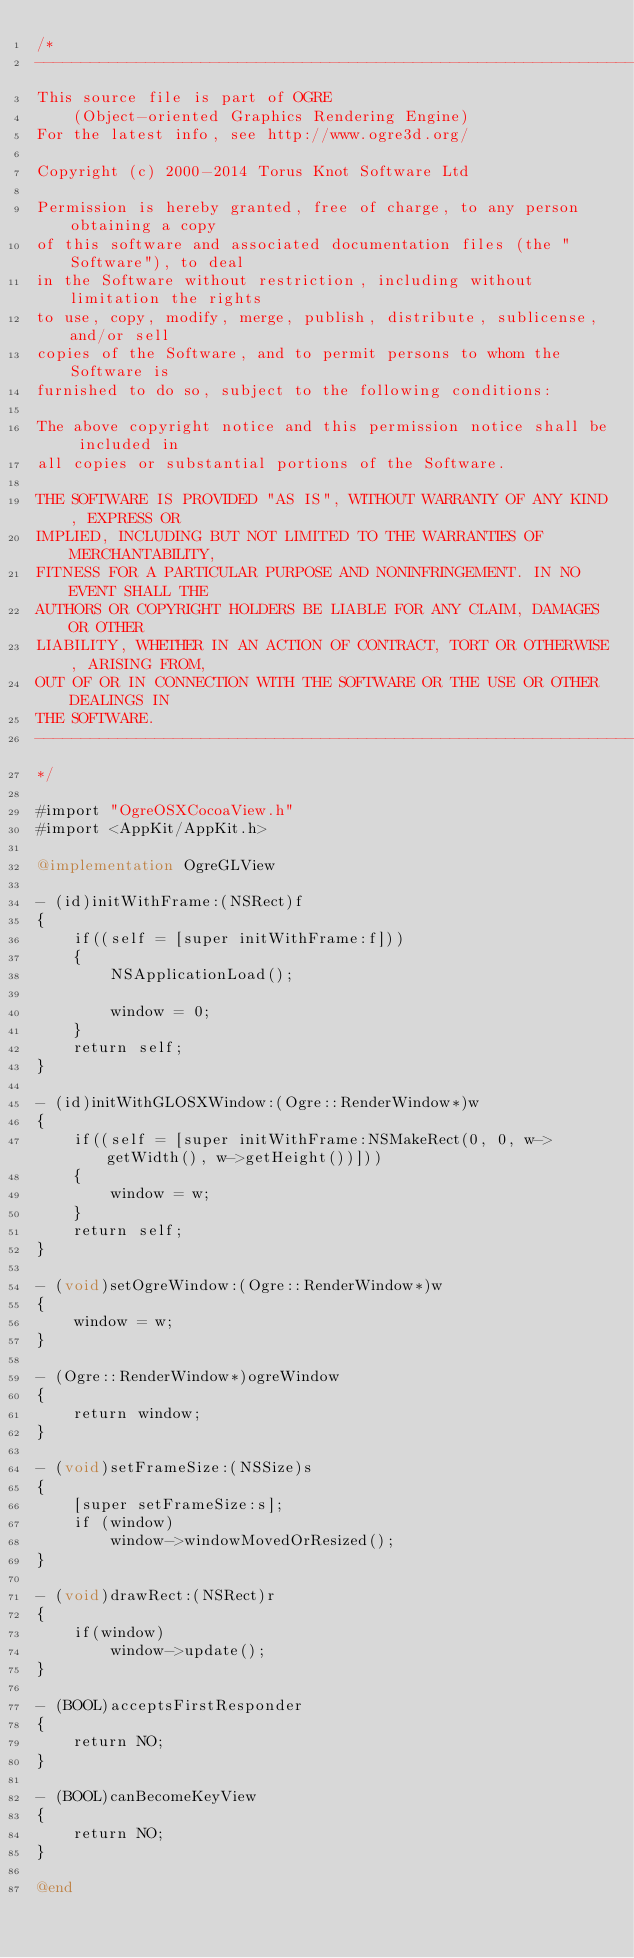Convert code to text. <code><loc_0><loc_0><loc_500><loc_500><_ObjectiveC_>/*
-----------------------------------------------------------------------------
This source file is part of OGRE
    (Object-oriented Graphics Rendering Engine)
For the latest info, see http://www.ogre3d.org/

Copyright (c) 2000-2014 Torus Knot Software Ltd

Permission is hereby granted, free of charge, to any person obtaining a copy
of this software and associated documentation files (the "Software"), to deal
in the Software without restriction, including without limitation the rights
to use, copy, modify, merge, publish, distribute, sublicense, and/or sell
copies of the Software, and to permit persons to whom the Software is
furnished to do so, subject to the following conditions:

The above copyright notice and this permission notice shall be included in
all copies or substantial portions of the Software.

THE SOFTWARE IS PROVIDED "AS IS", WITHOUT WARRANTY OF ANY KIND, EXPRESS OR
IMPLIED, INCLUDING BUT NOT LIMITED TO THE WARRANTIES OF MERCHANTABILITY,
FITNESS FOR A PARTICULAR PURPOSE AND NONINFRINGEMENT. IN NO EVENT SHALL THE
AUTHORS OR COPYRIGHT HOLDERS BE LIABLE FOR ANY CLAIM, DAMAGES OR OTHER
LIABILITY, WHETHER IN AN ACTION OF CONTRACT, TORT OR OTHERWISE, ARISING FROM,
OUT OF OR IN CONNECTION WITH THE SOFTWARE OR THE USE OR OTHER DEALINGS IN
THE SOFTWARE.
-----------------------------------------------------------------------------
*/

#import "OgreOSXCocoaView.h"
#import <AppKit/AppKit.h>

@implementation OgreGLView

- (id)initWithFrame:(NSRect)f
{
	if((self = [super initWithFrame:f]))
    {
        NSApplicationLoad();
        
        window = 0;
    }
	return self;
}

- (id)initWithGLOSXWindow:(Ogre::RenderWindow*)w
{
	if((self = [super initWithFrame:NSMakeRect(0, 0, w->getWidth(), w->getHeight())]))
    {
        window = w;
    }
	return self;
}

- (void)setOgreWindow:(Ogre::RenderWindow*)w
{
	window = w;
}

- (Ogre::RenderWindow*)ogreWindow
{
	return window;
}

- (void)setFrameSize:(NSSize)s
{
	[super setFrameSize:s];
    if (window)
        window->windowMovedOrResized();
}

- (void)drawRect:(NSRect)r
{
	if(window)
		window->update();
}

- (BOOL)acceptsFirstResponder
{
    return NO;
}

- (BOOL)canBecomeKeyView
{
    return NO;
}

@end
</code> 